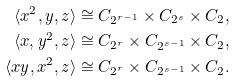<formula> <loc_0><loc_0><loc_500><loc_500>\langle x ^ { 2 } , y , z \rangle & \cong C _ { 2 ^ { r - 1 } } \times C _ { 2 ^ { s } } \times C _ { 2 } , \\ \langle x , y ^ { 2 } , z \rangle & \cong C _ { 2 ^ { r } } \times C _ { 2 ^ { s - 1 } } \times C _ { 2 } , \\ \langle x y , x ^ { 2 } , z \rangle & \cong C _ { 2 ^ { r } } \times C _ { 2 ^ { s - 1 } } \times C _ { 2 } .</formula> 